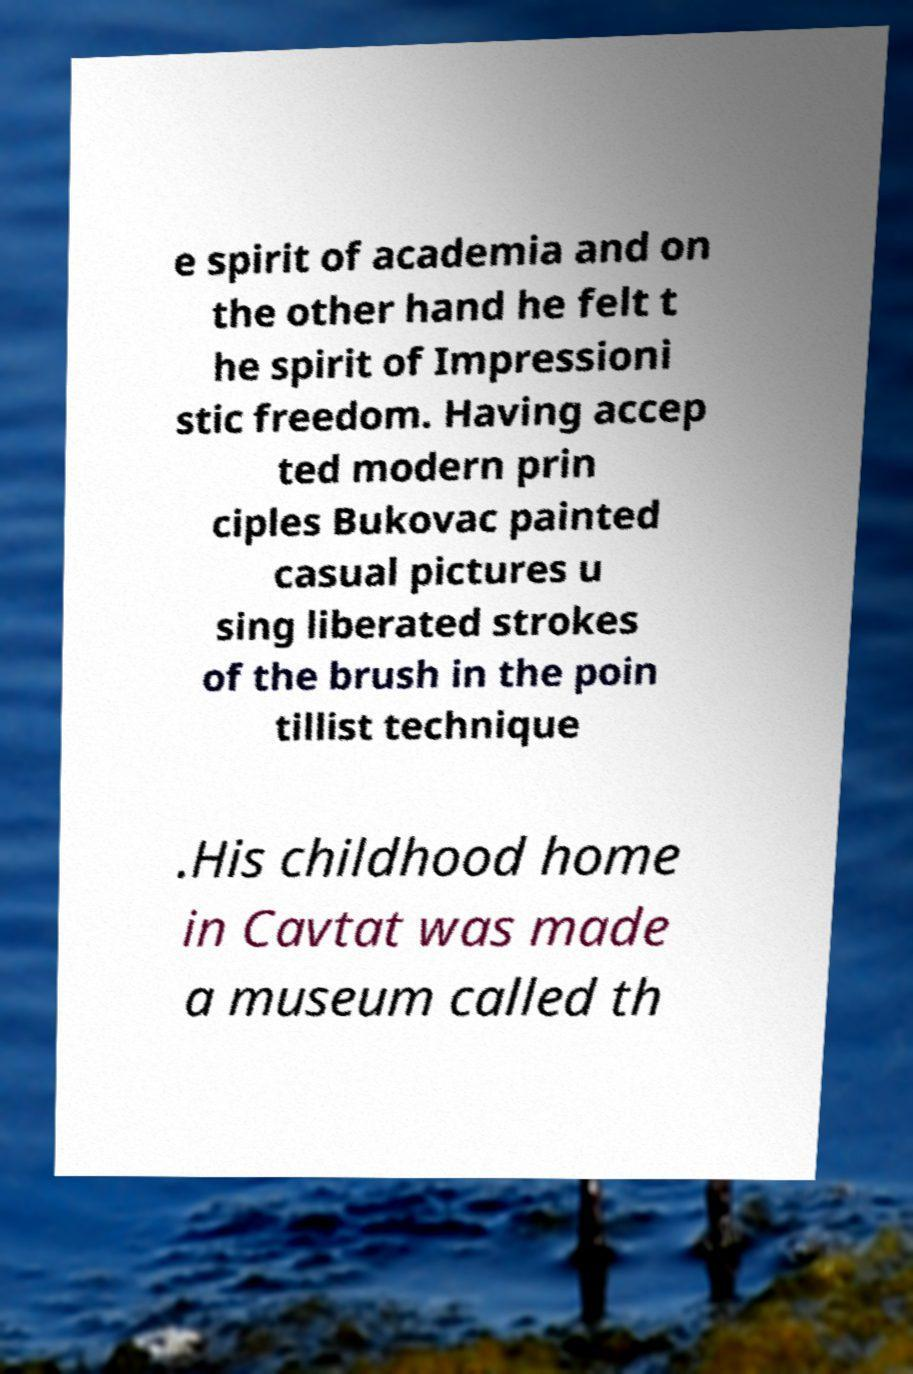There's text embedded in this image that I need extracted. Can you transcribe it verbatim? e spirit of academia and on the other hand he felt t he spirit of Impressioni stic freedom. Having accep ted modern prin ciples Bukovac painted casual pictures u sing liberated strokes of the brush in the poin tillist technique .His childhood home in Cavtat was made a museum called th 